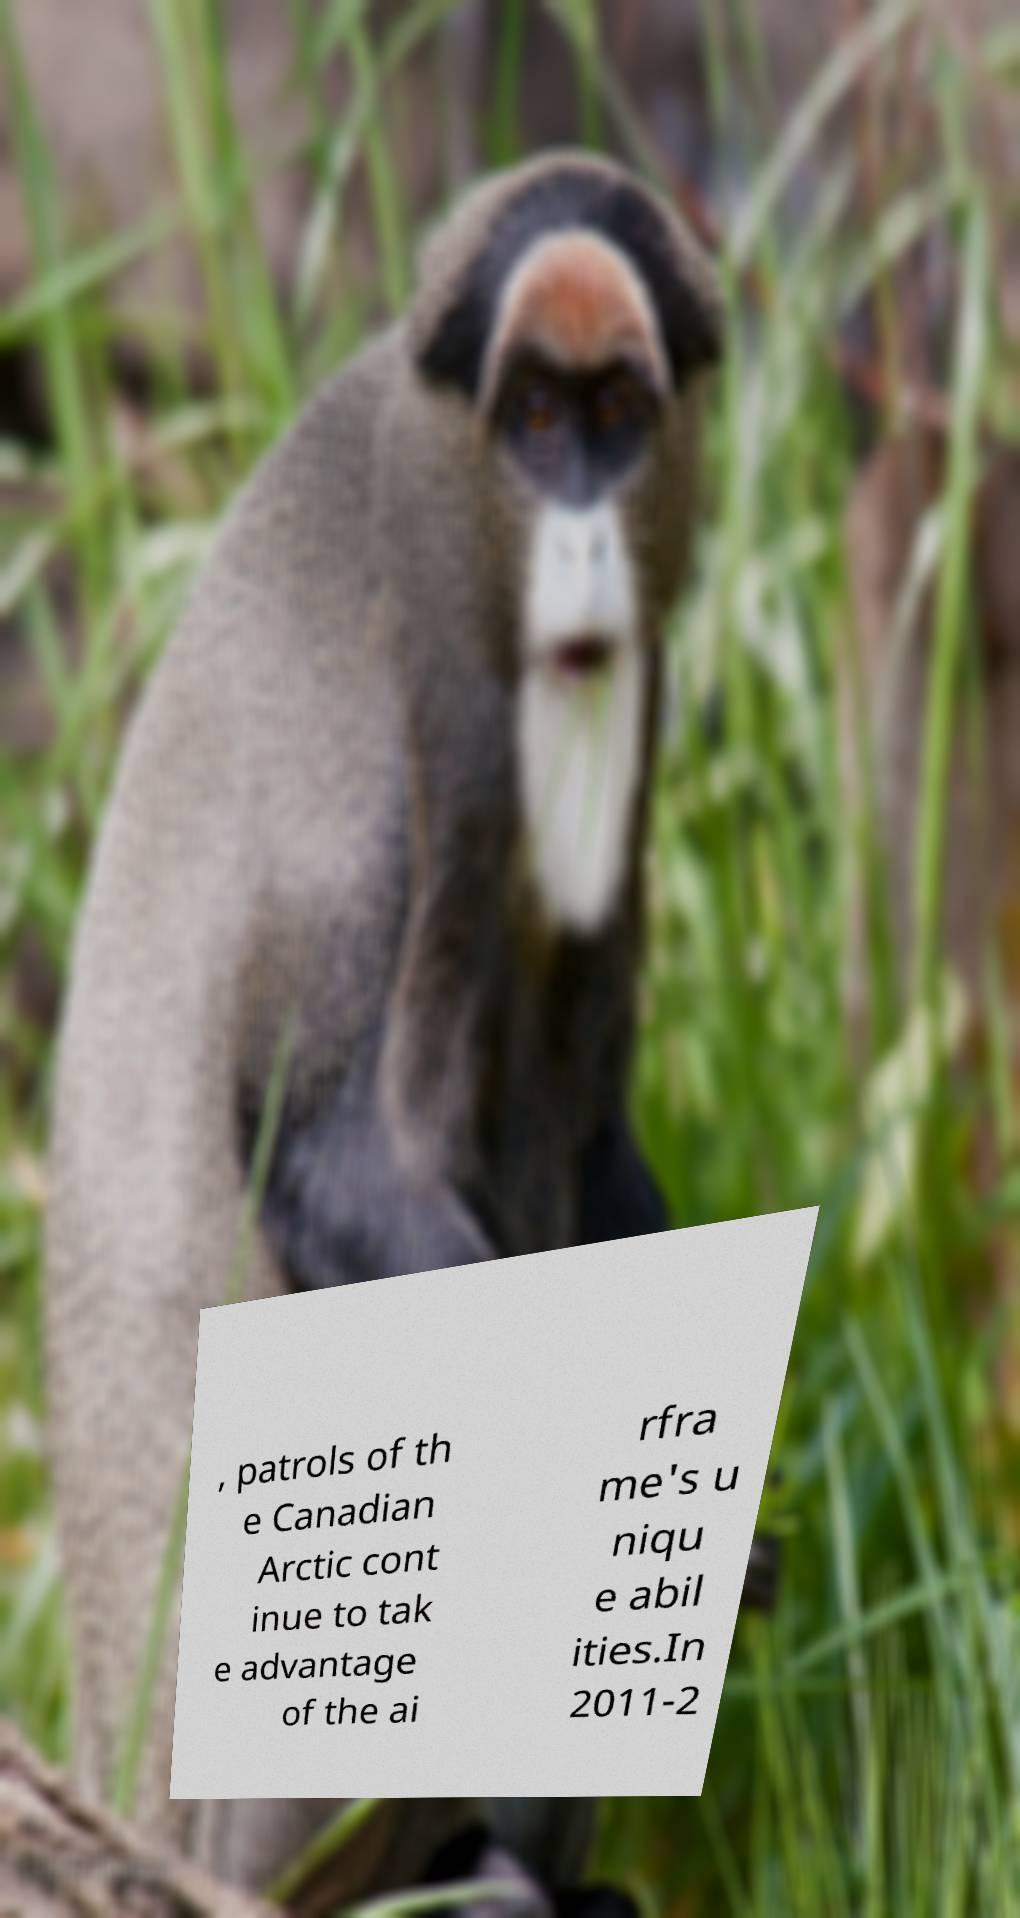Can you read and provide the text displayed in the image?This photo seems to have some interesting text. Can you extract and type it out for me? , patrols of th e Canadian Arctic cont inue to tak e advantage of the ai rfra me's u niqu e abil ities.In 2011-2 